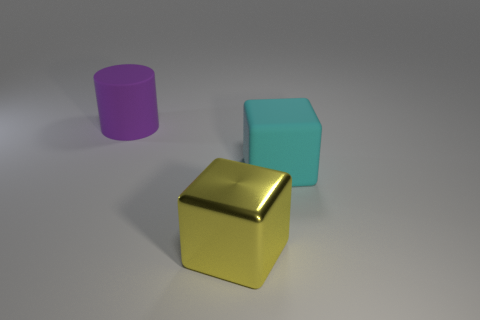Add 3 large red matte cubes. How many objects exist? 6 Subtract all cyan cubes. How many cubes are left? 1 Subtract all cubes. How many objects are left? 1 Subtract all metallic cubes. Subtract all matte objects. How many objects are left? 0 Add 2 big cyan rubber blocks. How many big cyan rubber blocks are left? 3 Add 1 blue rubber objects. How many blue rubber objects exist? 1 Subtract 0 brown cylinders. How many objects are left? 3 Subtract all purple blocks. Subtract all cyan cylinders. How many blocks are left? 2 